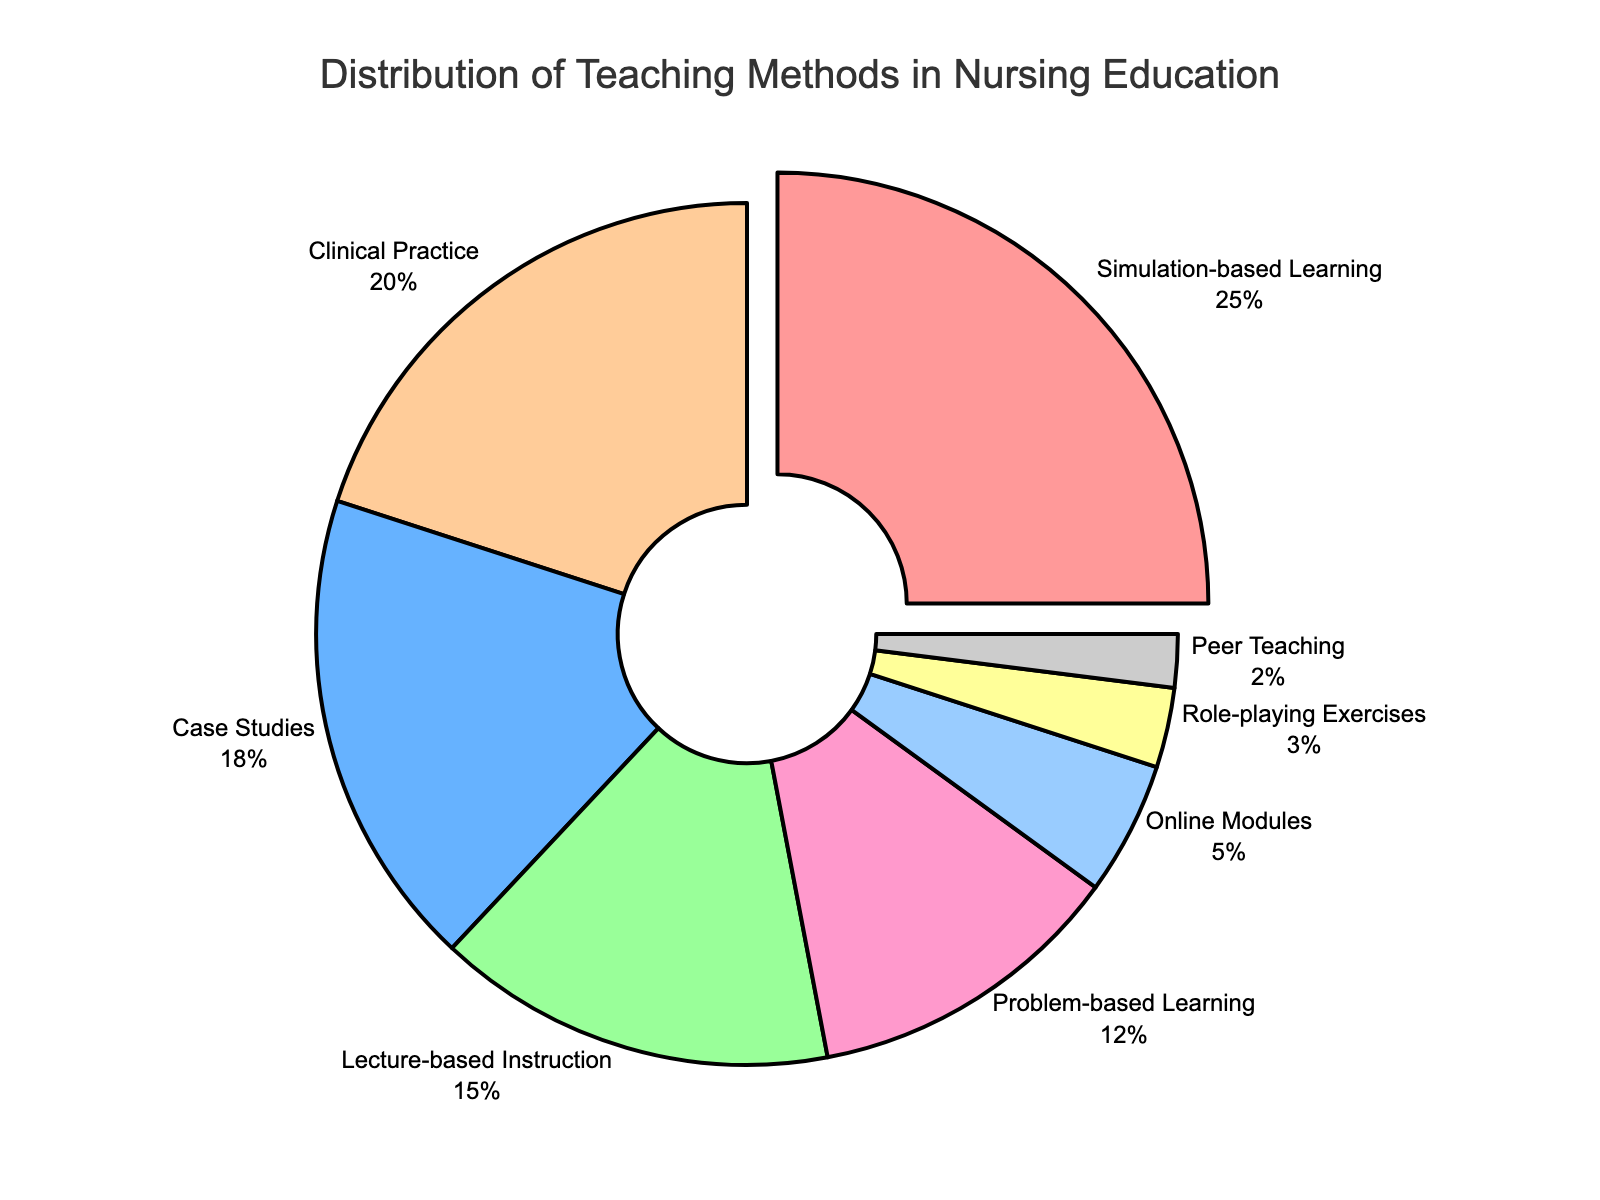What's the percentage of the three least common teaching methods combined? Identify the three least common teaching methods: Peer Teaching (2%), Role-playing Exercises (3%), and Online Modules (5%). Add these percentages together: 2% + 3% + 5% = 10%
Answer: 10% Which teaching method has the highest percentage? Locate the segment with the largest percentage labeled, which is Simulation-based Learning with 25%.
Answer: Simulation-based Learning How much more common is Clinical Practice than Problem-based Learning? Compare the percentages of Clinical Practice (20%) and Problem-based Learning (12%). Subtract the smaller percentage from the larger one: 20% - 12% = 8%
Answer: 8% Which teaching methods together comprise more than half of the total methods used? Identify the teaching methods and their respective percentages: Simulation-based Learning (25%), Case Studies (18%), Lecture-based Instruction (15%), and Clinical Practice (20%). Add the percentages progressively until the sum surpasses 50%. Simulation-based Learning (25%) + Case Studies (18%) = 43%. Adding Lecture-based Instruction (15%) brings the total to 58%, surpassing 50%.
Answer: Simulation-based Learning, Case Studies, and Lecture-based Instruction How does the percentage of Lecture-based Instruction compare to Online Modules? Locate the percentages for Lecture-based Instruction (15%) and Online Modules (5%). Calculate the difference: 15% - 5% = 10%. Lecture-based Instruction is 10% more common.
Answer: 10% Which segment is highlighted or pulled out from the pie chart? Observe the pie chart and identify the segment that is visually separated or pulled out from the whole. The highlighted segment is Simulation-based Learning.
Answer: Simulation-based Learning What is the average percentage of the five most common teaching methods? Identify the five most common methods based on their percentages: Simulation-based Learning (25%), Clinical Practice (20%), Case Studies (18%), Lecture-based Instruction (15%), and Problem-based Learning (12%). Compute the average by summing these percentages and dividing by 5: (25% + 20% + 18% + 15% + 12%) / 5 = 18%.
Answer: 18% By how much does the percentage of Case Studies exceed that of Role-playing Exercises? Compare the percentages for Case Studies (18%) and Role-playing Exercises (3%). Subtract the smaller percentage from the larger one: 18% - 3% = 15%.
Answer: 15% What is the color of the section representing Peer Teaching? Look for the segment labeled Peer Teaching and identify its color, which is grey.
Answer: Grey Which teaching method occupies one-fifth of the pie chart? Identify the segment that covers 20% of the pie, which is one-fifth of 100%. The segment labeled with 20% is Clinical Practice.
Answer: Clinical Practice 